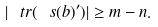Convert formula to latex. <formula><loc_0><loc_0><loc_500><loc_500>| \ t r ( \ s ( b ) ^ { \prime } ) | \geq m - n .</formula> 